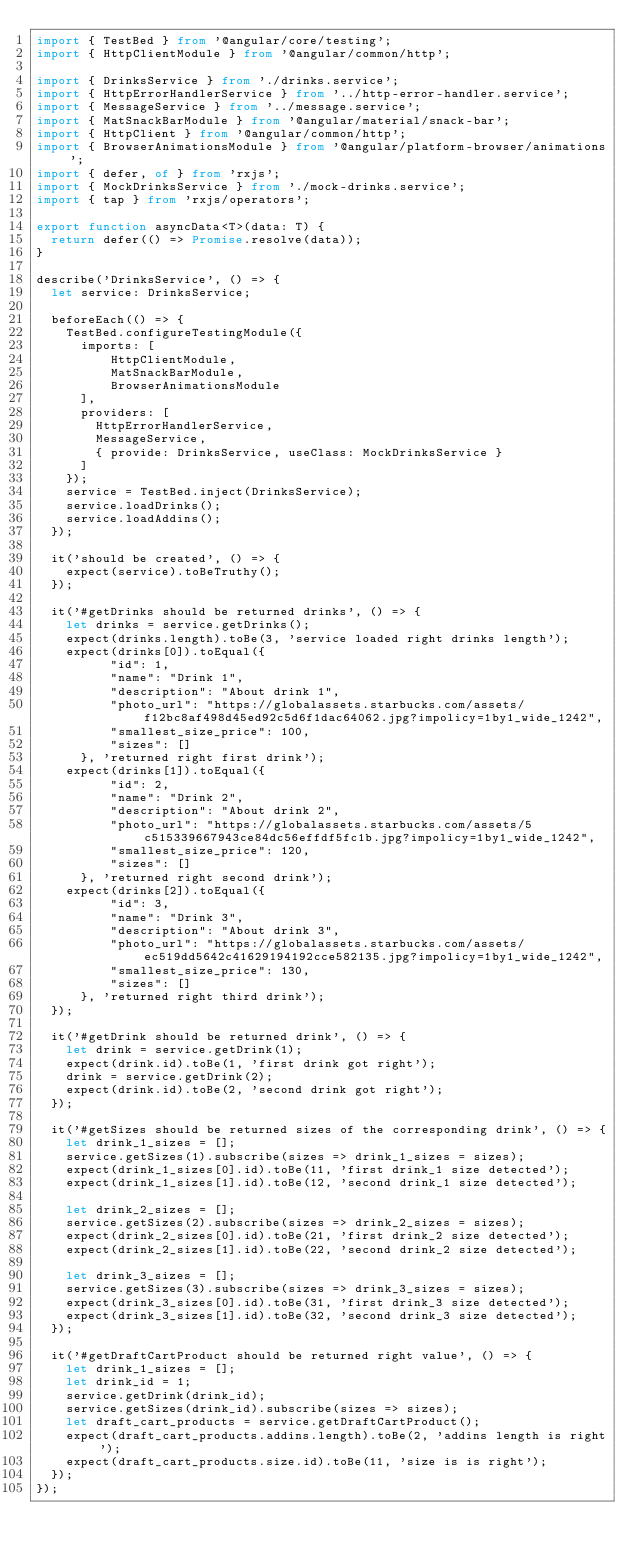<code> <loc_0><loc_0><loc_500><loc_500><_TypeScript_>import { TestBed } from '@angular/core/testing';
import { HttpClientModule } from '@angular/common/http';

import { DrinksService } from './drinks.service';
import { HttpErrorHandlerService } from '../http-error-handler.service';
import { MessageService } from '../message.service';
import { MatSnackBarModule } from '@angular/material/snack-bar';
import { HttpClient } from '@angular/common/http';
import { BrowserAnimationsModule } from '@angular/platform-browser/animations';
import { defer, of } from 'rxjs';
import { MockDrinksService } from './mock-drinks.service';
import { tap } from 'rxjs/operators';

export function asyncData<T>(data: T) {
  return defer(() => Promise.resolve(data));
}

describe('DrinksService', () => {
	let service: DrinksService;

	beforeEach(() => {
		TestBed.configureTestingModule({
			imports: [
		    	HttpClientModule,
		    	MatSnackBarModule,
		    	BrowserAnimationsModule
			],
			providers: [
				HttpErrorHandlerService,
				MessageService,
				{ provide: DrinksService, useClass: MockDrinksService }
			]
		});
		service = TestBed.inject(DrinksService);
		service.loadDrinks();
		service.loadAddins();
	});

	it('should be created', () => {
		expect(service).toBeTruthy();
	});

	it('#getDrinks should be returned drinks', () => {
		let drinks = service.getDrinks();
		expect(drinks.length).toBe(3, 'service loaded right drinks length');
		expect(drinks[0]).toEqual({
	        "id": 1,
	        "name": "Drink 1",
	        "description": "About drink 1",
	        "photo_url": "https://globalassets.starbucks.com/assets/f12bc8af498d45ed92c5d6f1dac64062.jpg?impolicy=1by1_wide_1242",
	        "smallest_size_price": 100,
	        "sizes": []
	    }, 'returned right first drink');
		expect(drinks[1]).toEqual({
	        "id": 2,
	        "name": "Drink 2",
	        "description": "About drink 2",
	        "photo_url": "https://globalassets.starbucks.com/assets/5c515339667943ce84dc56effdf5fc1b.jpg?impolicy=1by1_wide_1242",
	        "smallest_size_price": 120,
	        "sizes": []
	    }, 'returned right second drink');
		expect(drinks[2]).toEqual({
	        "id": 3,
	        "name": "Drink 3",
	        "description": "About drink 3",
	        "photo_url": "https://globalassets.starbucks.com/assets/ec519dd5642c41629194192cce582135.jpg?impolicy=1by1_wide_1242",
	        "smallest_size_price": 130,
	        "sizes": []
	    }, 'returned right third drink');
	});

	it('#getDrink should be returned drink', () => {
		let drink = service.getDrink(1);
		expect(drink.id).toBe(1, 'first drink got right');
		drink = service.getDrink(2);
		expect(drink.id).toBe(2, 'second drink got right');
	});

	it('#getSizes should be returned sizes of the corresponding drink', () => {
		let drink_1_sizes = [];
		service.getSizes(1).subscribe(sizes => drink_1_sizes = sizes);
		expect(drink_1_sizes[0].id).toBe(11, 'first drink_1 size detected');
		expect(drink_1_sizes[1].id).toBe(12, 'second drink_1 size detected');

		let drink_2_sizes = [];
		service.getSizes(2).subscribe(sizes => drink_2_sizes = sizes);
		expect(drink_2_sizes[0].id).toBe(21, 'first drink_2 size detected');
		expect(drink_2_sizes[1].id).toBe(22, 'second drink_2 size detected');

		let drink_3_sizes = [];
		service.getSizes(3).subscribe(sizes => drink_3_sizes = sizes);
		expect(drink_3_sizes[0].id).toBe(31, 'first drink_3 size detected');
		expect(drink_3_sizes[1].id).toBe(32, 'second drink_3 size detected');
	});

	it('#getDraftCartProduct should be returned right value', () => {
		let drink_1_sizes = [];
		let drink_id = 1;
		service.getDrink(drink_id);
		service.getSizes(drink_id).subscribe(sizes => sizes);
		let draft_cart_products = service.getDraftCartProduct();
		expect(draft_cart_products.addins.length).toBe(2, 'addins length is right');
		expect(draft_cart_products.size.id).toBe(11, 'size is is right');
	});
});
</code> 